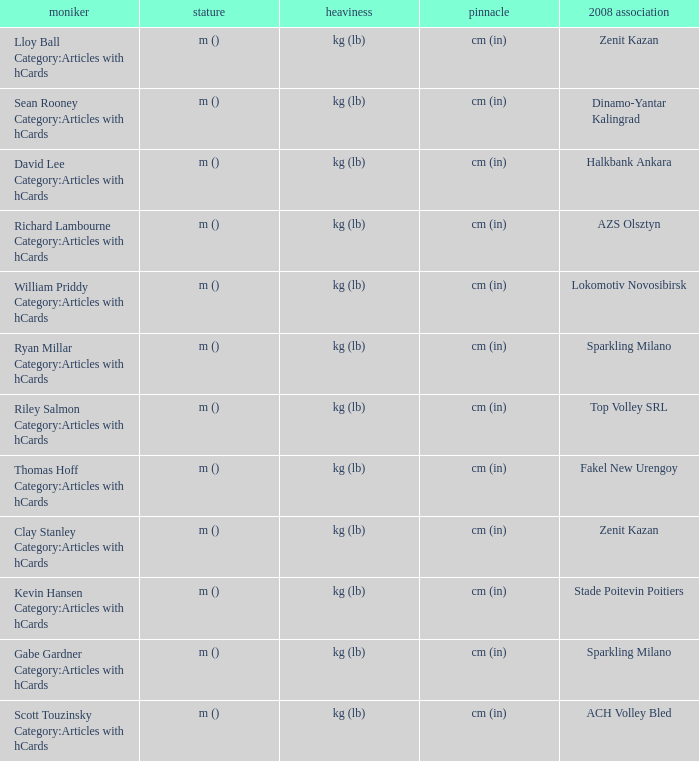What shows for height for the 2008 club of Stade Poitevin Poitiers? M (). 